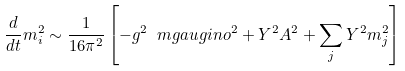Convert formula to latex. <formula><loc_0><loc_0><loc_500><loc_500>\frac { d } { d t } m ^ { 2 } _ { i } \sim \frac { 1 } { 1 6 \pi ^ { 2 } } \left [ - g ^ { 2 } \ m g a u g i n o ^ { 2 } + Y ^ { 2 } A ^ { 2 } + \sum _ { j } Y ^ { 2 } m _ { j } ^ { 2 } \right ]</formula> 